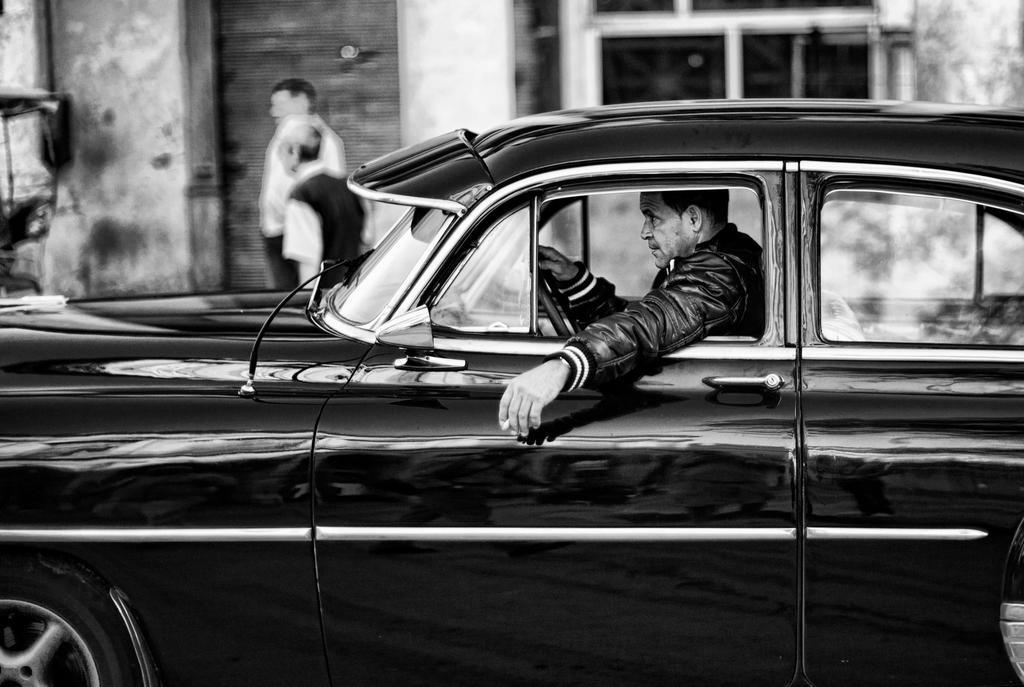What is the man in the image doing? The man is riding a car in the image. Can you describe the scene involving the two men in the image? There are two men standing in front of a building in the image. What type of furniture can be seen in the image? There is no furniture present in the image. What is the government's stance on the situation depicted in the image? The image does not depict a situation that would involve a government stance. 